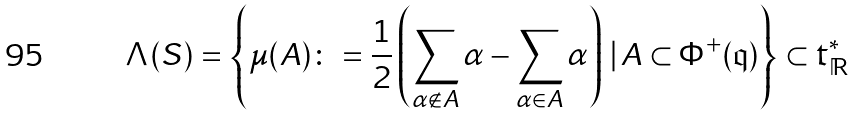<formula> <loc_0><loc_0><loc_500><loc_500>\Lambda ( { S } ) = \left \{ \mu ( A ) \colon = \frac { 1 } { 2 } \left ( \sum _ { \alpha \not \in A } \alpha - \sum _ { \alpha \in A } \alpha \right ) \, | \, A \subset \Phi ^ { + } ( { \mathfrak q } ) \right \} \subset \mathfrak { t } _ { \mathbb { R } } ^ { * }</formula> 